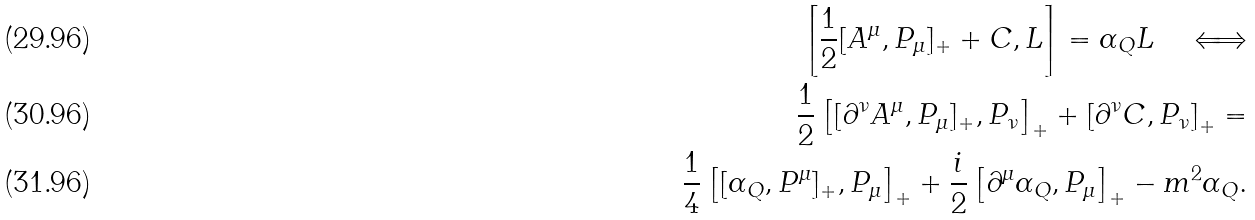Convert formula to latex. <formula><loc_0><loc_0><loc_500><loc_500>\left [ \frac { 1 } { 2 } [ A ^ { \mu } , P _ { \mu } ] _ { + } + C , L \right ] = \alpha _ { Q } L \quad \Longleftrightarrow \\ \frac { 1 } { 2 } \left [ [ \partial ^ { \nu } A ^ { \mu } , P _ { \mu } ] _ { + } , P _ { \nu } \right ] _ { + } + \left [ \partial ^ { \nu } C , P _ { \nu } \right ] _ { + } = \\ \frac { 1 } { 4 } \left [ [ \alpha _ { Q } , P ^ { \mu } ] _ { + } , P _ { \mu } \right ] _ { + } + \frac { i } { 2 } \left [ \partial ^ { \mu } \alpha _ { Q } , P _ { \mu } \right ] _ { + } - m ^ { 2 } \alpha _ { Q } .</formula> 